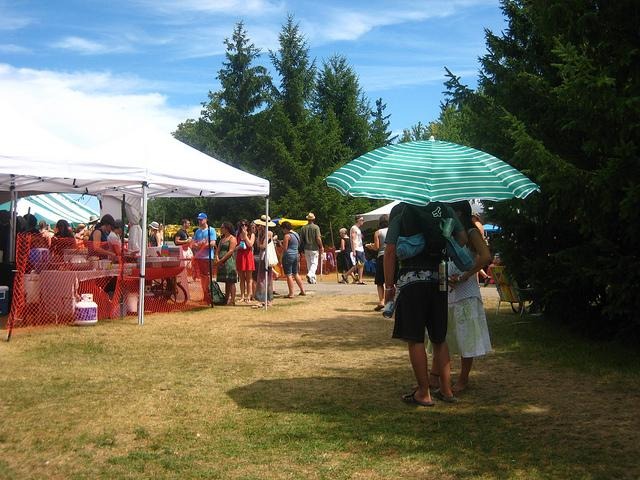What is the green umbrella being used to block? Please explain your reasoning. sun. It's not raining, and c and d can't be stopped with an umbrella. 